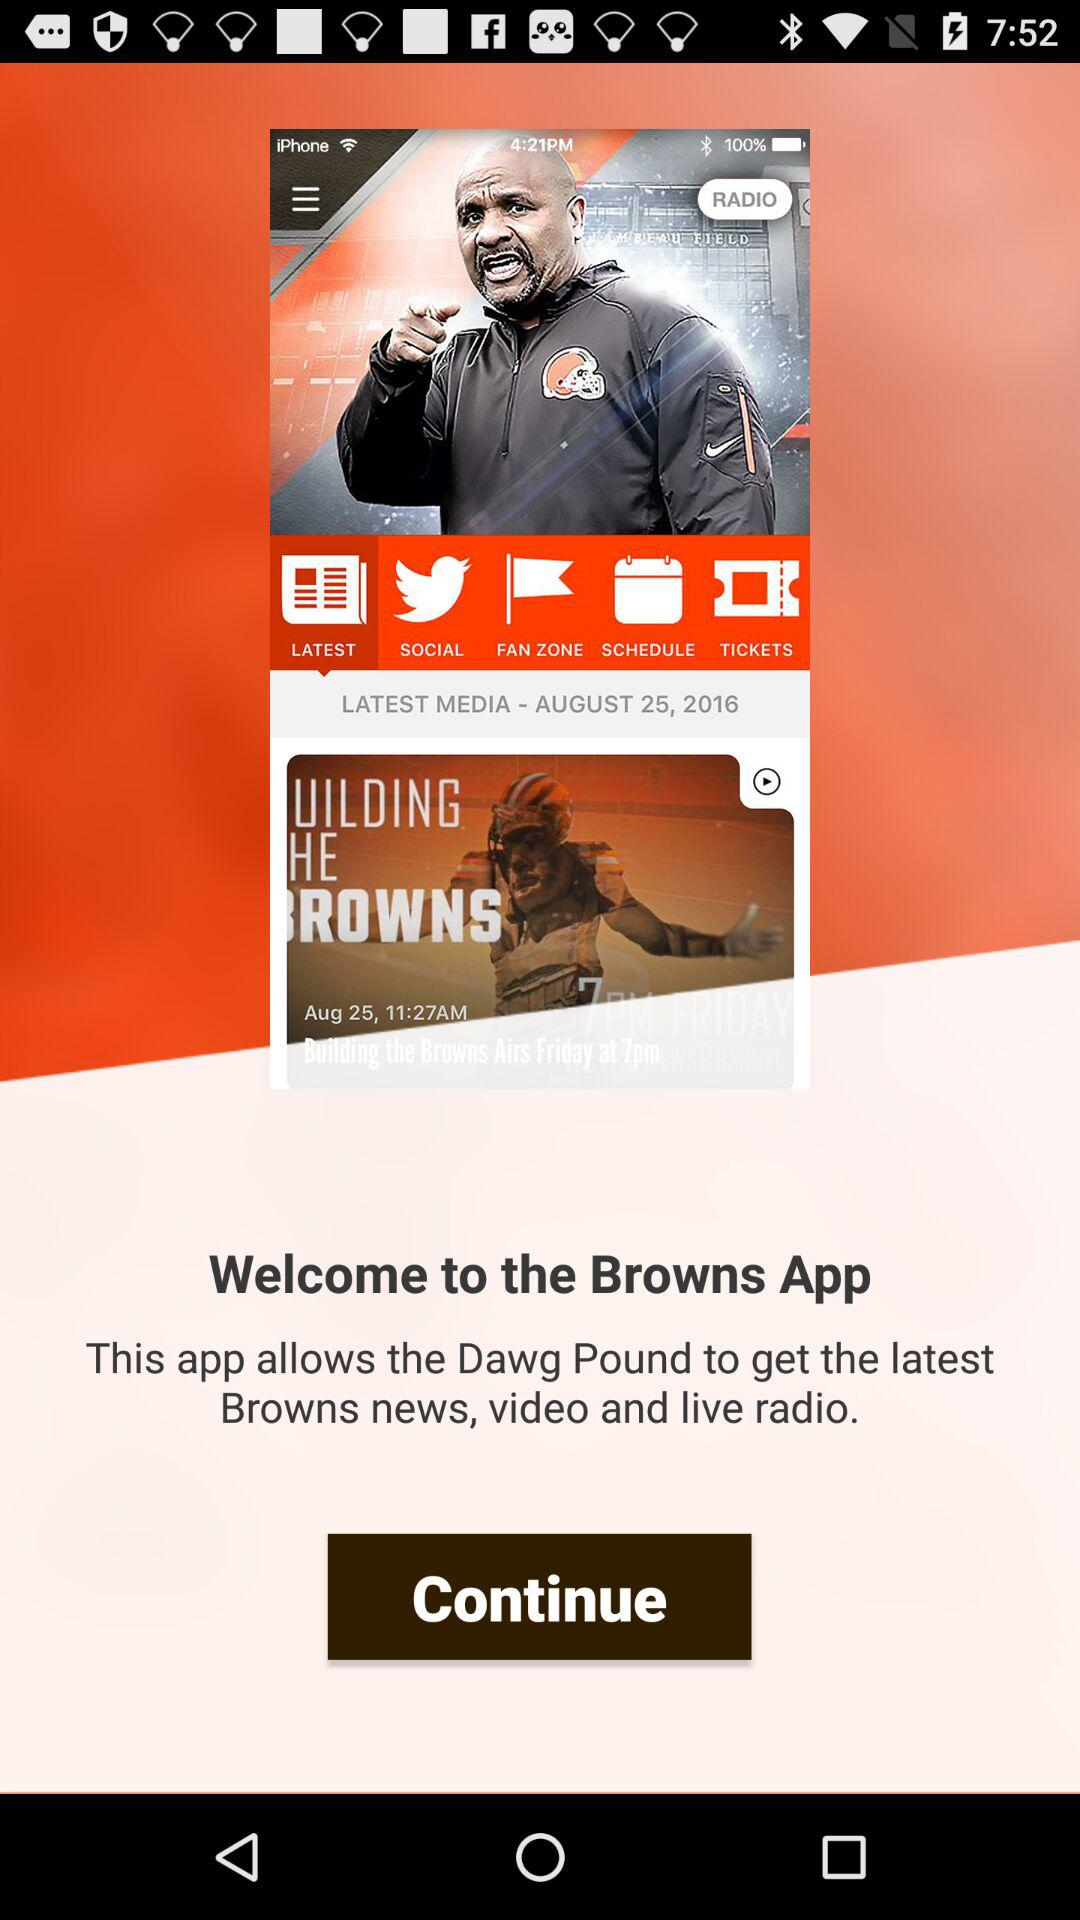Which tab is selected?
When the provided information is insufficient, respond with <no answer>. <no answer> 